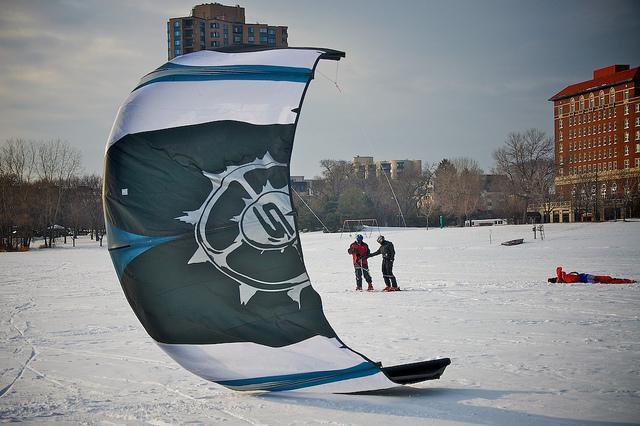How many elephants are there?
Give a very brief answer. 0. 